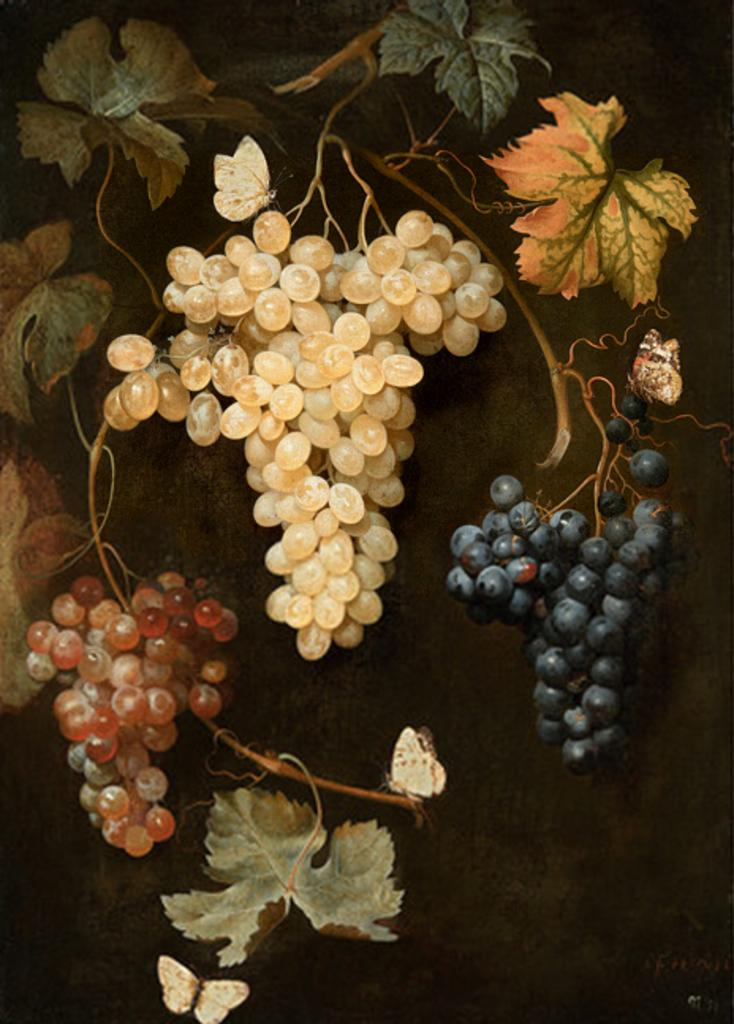What type of plant is visible in the image? There is a plant in the image, but the specific type cannot be determined from the provided facts. What type of fruit is present in the image? There are grapes in the image. What can be observed about the lighting in the image? The background of the image is dark. What type of game is being played in the image? There is no game present in the image; it features a plant and grapes. Can you tell me who the coach is in the image? There is no coach present in the image; it features a plant and grapes. 